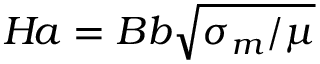Convert formula to latex. <formula><loc_0><loc_0><loc_500><loc_500>H \, a = B b \sqrt { \sigma _ { m } / \mu }</formula> 